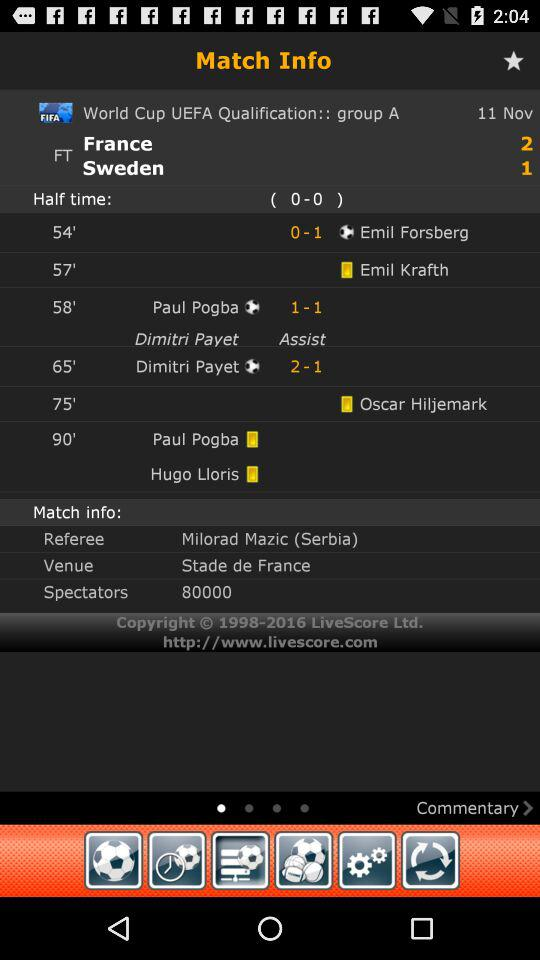How many more goals did France score than Sweden?
Answer the question using a single word or phrase. 1 